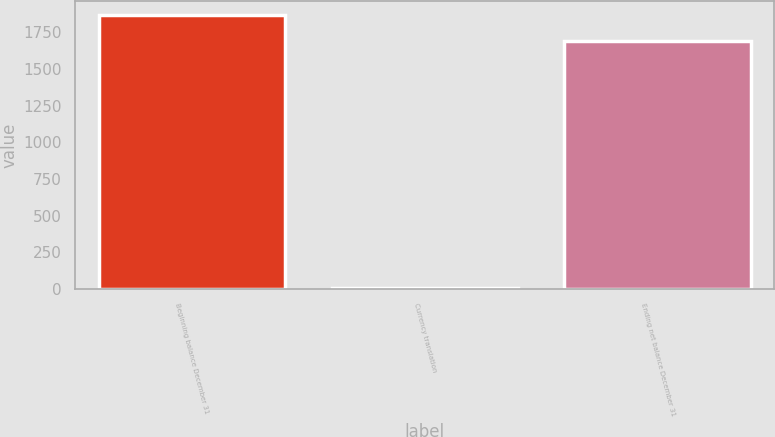Convert chart to OTSL. <chart><loc_0><loc_0><loc_500><loc_500><bar_chart><fcel>Beginning balance December 31<fcel>Currency translation<fcel>Ending net balance December 31<nl><fcel>1867.7<fcel>8<fcel>1693<nl></chart> 